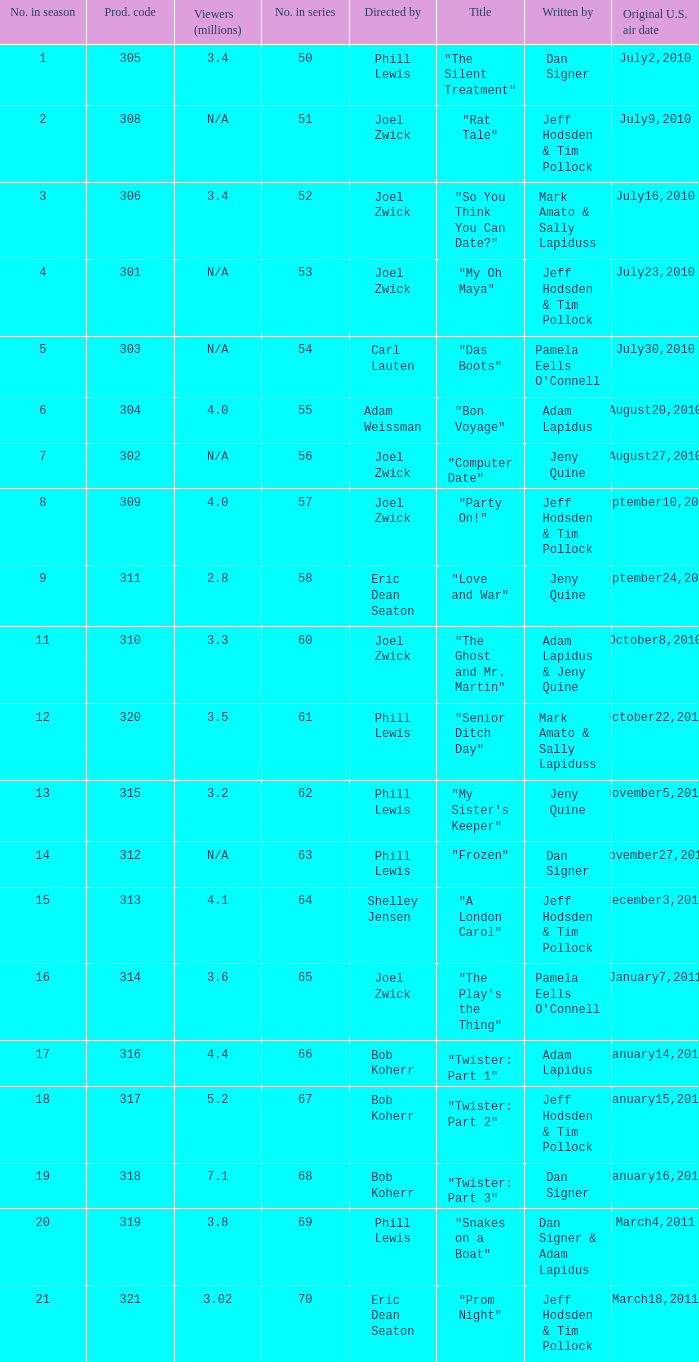What episode number was titled "my oh maya"? 4.0. 